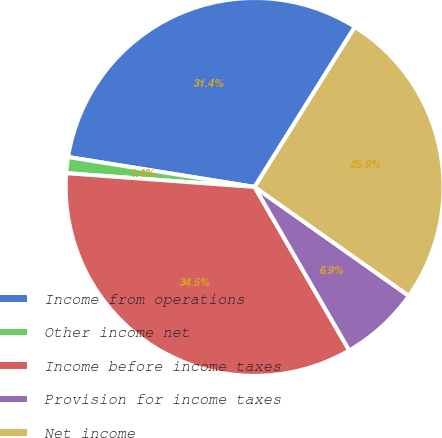Convert chart. <chart><loc_0><loc_0><loc_500><loc_500><pie_chart><fcel>Income from operations<fcel>Other income net<fcel>Income before income taxes<fcel>Provision for income taxes<fcel>Net income<nl><fcel>31.37%<fcel>1.37%<fcel>34.51%<fcel>6.86%<fcel>25.88%<nl></chart> 